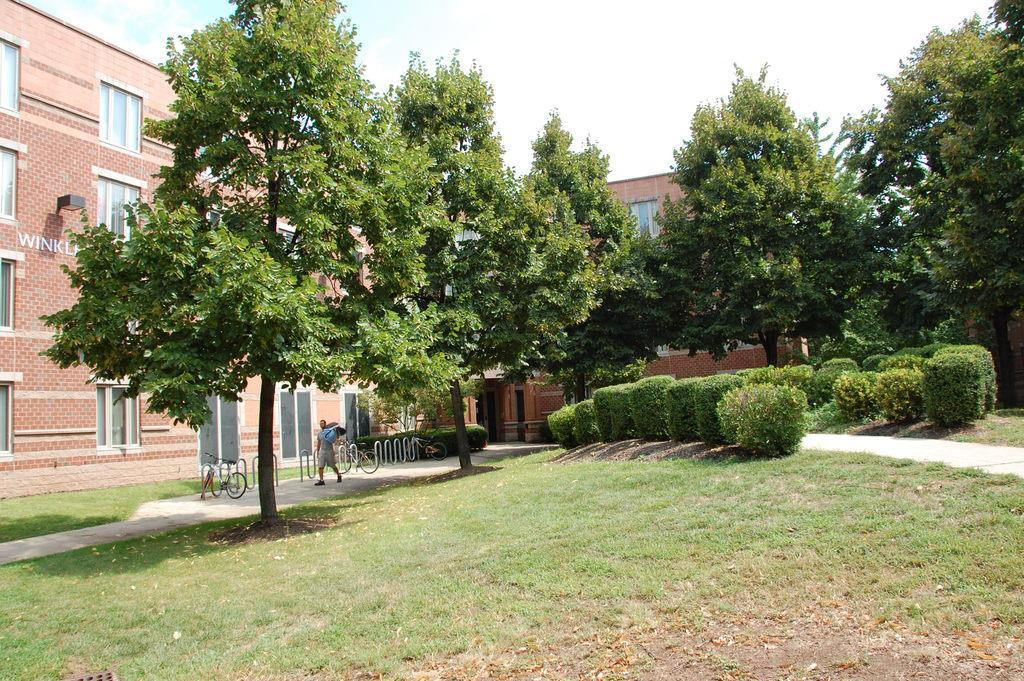Could you give a brief overview of what you see in this image? In this image there is a building, in front of the building there are trees, beneath the trees there is a person holding something and walking on the path and there is a bicycle. On the right side of the image there are few plants and grass on the surface. In the background there is a sky. 